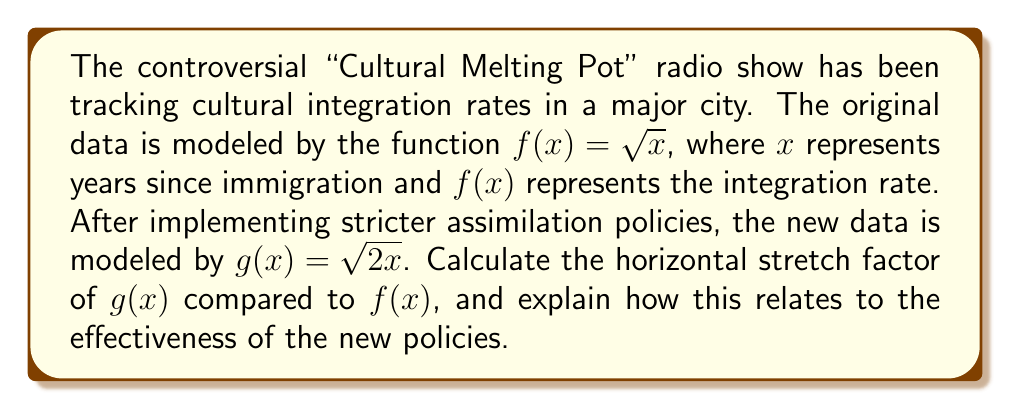Provide a solution to this math problem. To determine the horizontal stretch factor, we need to compare the functions $f(x) = \sqrt{x}$ and $g(x) = \sqrt{2x}$.

1) First, let's rewrite $g(x)$ in terms of $f(x)$:
   $g(x) = \sqrt{2x} = \sqrt{2} \cdot \sqrt{x} = \sqrt{2} \cdot f(x)$

2) This form doesn't clearly show the horizontal stretch. To see it, we need to manipulate $g(x)$ further:
   $g(x) = \sqrt{2x} = \sqrt{2} \cdot \sqrt{x} = f(\sqrt{2} \cdot x)$

3) Now we can see that $g(x) = f(\sqrt{2} \cdot x)$. This means that to get the same $y$-value in $g(x)$ as in $f(x)$, we need to input $x/\sqrt{2}$ instead of $x$.

4) The general form of a horizontal stretch is $f(x/k)$, where $k$ is the stretch factor. In our case:
   $g(x) = f(x/(\frac{1}{\sqrt{2}})) = f(\sqrt{2} \cdot x)$

5) Therefore, the horizontal stretch factor is $1/\sqrt{2} = \sqrt{2}/2 \approx 0.707$

This means the graph of $g(x)$ is horizontally compressed by a factor of approximately 0.707 compared to $f(x)$. In the context of cultural integration, this indicates that under the new policies, immigrants are reaching the same level of integration in about 70.7% of the time it took before.
Answer: The horizontal stretch factor is $\frac{\sqrt{2}}{2}$ or approximately 0.707. 